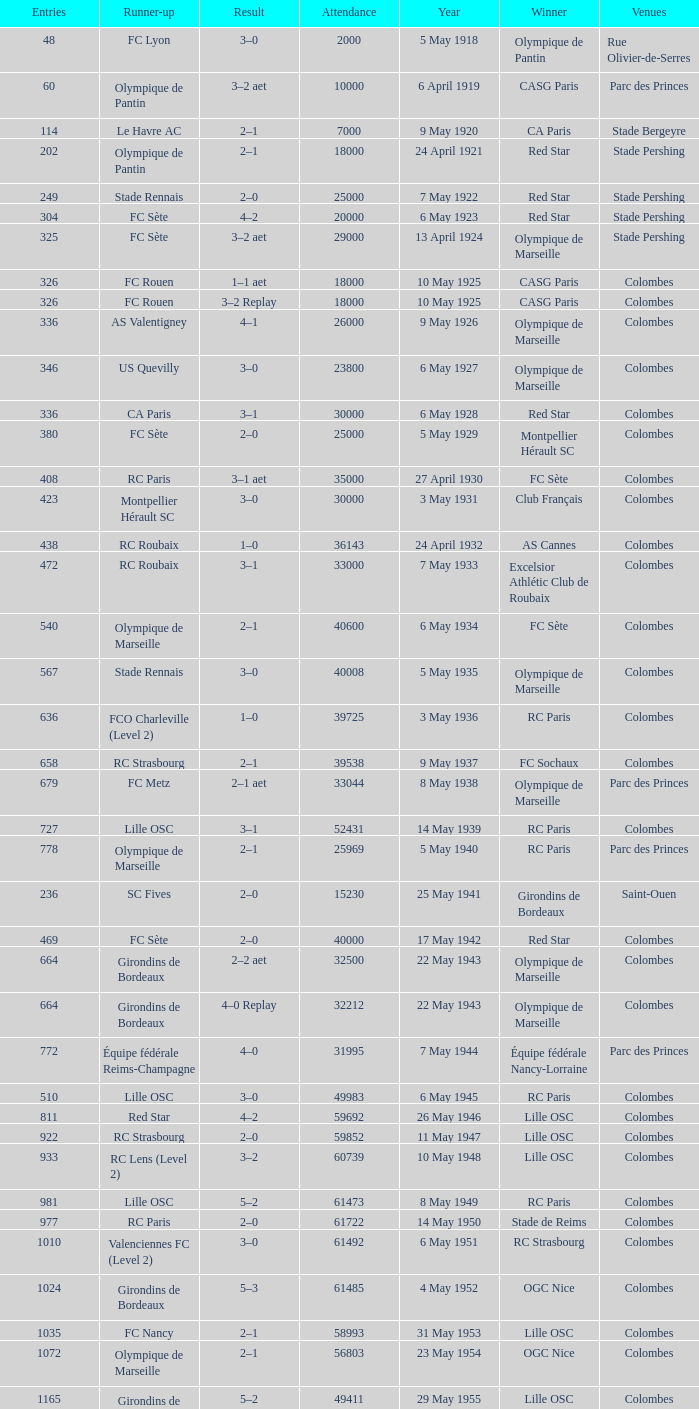What is the fewest recorded entrants against paris saint-germain? 6394.0. 